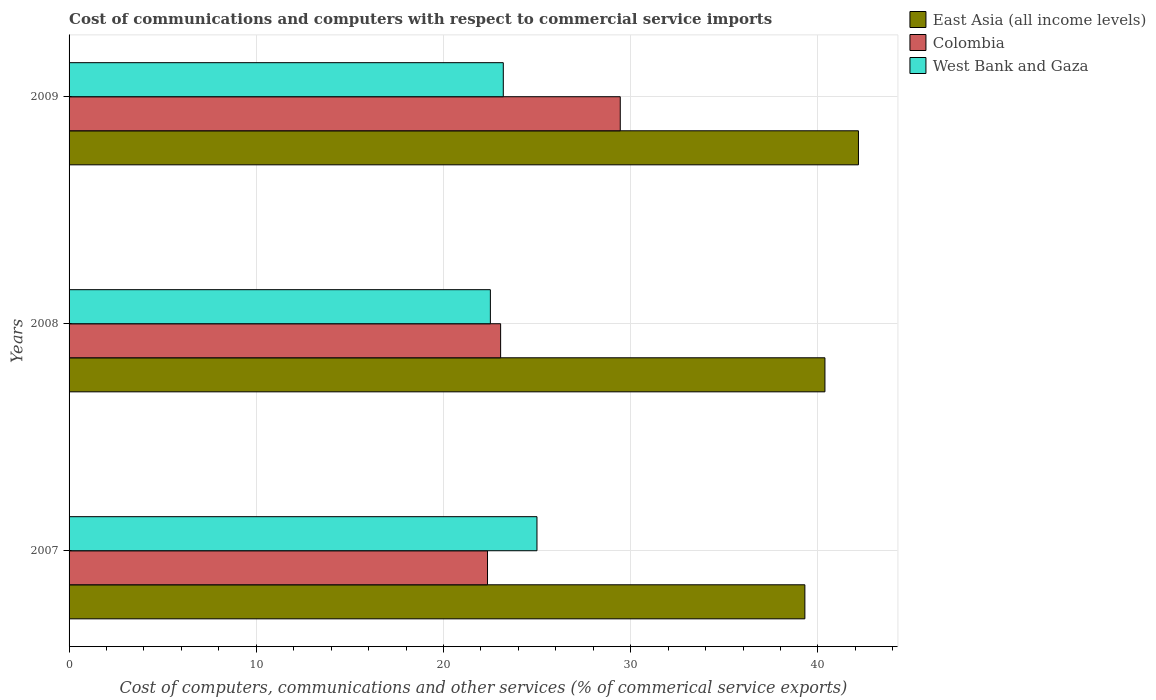How many different coloured bars are there?
Keep it short and to the point. 3. Are the number of bars on each tick of the Y-axis equal?
Make the answer very short. Yes. How many bars are there on the 2nd tick from the bottom?
Offer a very short reply. 3. What is the label of the 2nd group of bars from the top?
Give a very brief answer. 2008. What is the cost of communications and computers in West Bank and Gaza in 2007?
Make the answer very short. 24.99. Across all years, what is the maximum cost of communications and computers in Colombia?
Your answer should be very brief. 29.44. Across all years, what is the minimum cost of communications and computers in Colombia?
Offer a very short reply. 22.35. In which year was the cost of communications and computers in Colombia minimum?
Ensure brevity in your answer.  2007. What is the total cost of communications and computers in West Bank and Gaza in the graph?
Ensure brevity in your answer.  70.69. What is the difference between the cost of communications and computers in Colombia in 2008 and that in 2009?
Keep it short and to the point. -6.39. What is the difference between the cost of communications and computers in East Asia (all income levels) in 2009 and the cost of communications and computers in West Bank and Gaza in 2008?
Give a very brief answer. 19.66. What is the average cost of communications and computers in West Bank and Gaza per year?
Provide a succinct answer. 23.56. In the year 2007, what is the difference between the cost of communications and computers in East Asia (all income levels) and cost of communications and computers in West Bank and Gaza?
Your response must be concise. 14.31. In how many years, is the cost of communications and computers in West Bank and Gaza greater than 36 %?
Provide a succinct answer. 0. What is the ratio of the cost of communications and computers in West Bank and Gaza in 2008 to that in 2009?
Give a very brief answer. 0.97. Is the cost of communications and computers in Colombia in 2007 less than that in 2008?
Your answer should be compact. Yes. What is the difference between the highest and the second highest cost of communications and computers in Colombia?
Give a very brief answer. 6.39. What is the difference between the highest and the lowest cost of communications and computers in Colombia?
Your answer should be compact. 7.09. In how many years, is the cost of communications and computers in East Asia (all income levels) greater than the average cost of communications and computers in East Asia (all income levels) taken over all years?
Give a very brief answer. 1. Is the sum of the cost of communications and computers in West Bank and Gaza in 2008 and 2009 greater than the maximum cost of communications and computers in Colombia across all years?
Give a very brief answer. Yes. What does the 1st bar from the top in 2007 represents?
Offer a very short reply. West Bank and Gaza. What does the 1st bar from the bottom in 2008 represents?
Your answer should be very brief. East Asia (all income levels). Is it the case that in every year, the sum of the cost of communications and computers in Colombia and cost of communications and computers in West Bank and Gaza is greater than the cost of communications and computers in East Asia (all income levels)?
Keep it short and to the point. Yes. How many bars are there?
Keep it short and to the point. 9. Are all the bars in the graph horizontal?
Make the answer very short. Yes. What is the title of the graph?
Keep it short and to the point. Cost of communications and computers with respect to commercial service imports. What is the label or title of the X-axis?
Provide a short and direct response. Cost of computers, communications and other services (% of commerical service exports). What is the Cost of computers, communications and other services (% of commerical service exports) of East Asia (all income levels) in 2007?
Offer a terse response. 39.3. What is the Cost of computers, communications and other services (% of commerical service exports) in Colombia in 2007?
Offer a very short reply. 22.35. What is the Cost of computers, communications and other services (% of commerical service exports) of West Bank and Gaza in 2007?
Keep it short and to the point. 24.99. What is the Cost of computers, communications and other services (% of commerical service exports) of East Asia (all income levels) in 2008?
Your answer should be compact. 40.37. What is the Cost of computers, communications and other services (% of commerical service exports) in Colombia in 2008?
Offer a terse response. 23.05. What is the Cost of computers, communications and other services (% of commerical service exports) of West Bank and Gaza in 2008?
Provide a short and direct response. 22.5. What is the Cost of computers, communications and other services (% of commerical service exports) in East Asia (all income levels) in 2009?
Ensure brevity in your answer.  42.16. What is the Cost of computers, communications and other services (% of commerical service exports) in Colombia in 2009?
Your answer should be compact. 29.44. What is the Cost of computers, communications and other services (% of commerical service exports) of West Bank and Gaza in 2009?
Provide a succinct answer. 23.19. Across all years, what is the maximum Cost of computers, communications and other services (% of commerical service exports) of East Asia (all income levels)?
Provide a short and direct response. 42.16. Across all years, what is the maximum Cost of computers, communications and other services (% of commerical service exports) in Colombia?
Your answer should be compact. 29.44. Across all years, what is the maximum Cost of computers, communications and other services (% of commerical service exports) in West Bank and Gaza?
Ensure brevity in your answer.  24.99. Across all years, what is the minimum Cost of computers, communications and other services (% of commerical service exports) in East Asia (all income levels)?
Your answer should be compact. 39.3. Across all years, what is the minimum Cost of computers, communications and other services (% of commerical service exports) of Colombia?
Make the answer very short. 22.35. Across all years, what is the minimum Cost of computers, communications and other services (% of commerical service exports) in West Bank and Gaza?
Your answer should be compact. 22.5. What is the total Cost of computers, communications and other services (% of commerical service exports) in East Asia (all income levels) in the graph?
Keep it short and to the point. 121.84. What is the total Cost of computers, communications and other services (% of commerical service exports) of Colombia in the graph?
Your answer should be very brief. 74.84. What is the total Cost of computers, communications and other services (% of commerical service exports) of West Bank and Gaza in the graph?
Make the answer very short. 70.69. What is the difference between the Cost of computers, communications and other services (% of commerical service exports) of East Asia (all income levels) in 2007 and that in 2008?
Provide a short and direct response. -1.07. What is the difference between the Cost of computers, communications and other services (% of commerical service exports) of Colombia in 2007 and that in 2008?
Offer a very short reply. -0.7. What is the difference between the Cost of computers, communications and other services (% of commerical service exports) of West Bank and Gaza in 2007 and that in 2008?
Give a very brief answer. 2.49. What is the difference between the Cost of computers, communications and other services (% of commerical service exports) of East Asia (all income levels) in 2007 and that in 2009?
Offer a terse response. -2.86. What is the difference between the Cost of computers, communications and other services (% of commerical service exports) in Colombia in 2007 and that in 2009?
Offer a terse response. -7.09. What is the difference between the Cost of computers, communications and other services (% of commerical service exports) in West Bank and Gaza in 2007 and that in 2009?
Provide a short and direct response. 1.8. What is the difference between the Cost of computers, communications and other services (% of commerical service exports) of East Asia (all income levels) in 2008 and that in 2009?
Keep it short and to the point. -1.79. What is the difference between the Cost of computers, communications and other services (% of commerical service exports) of Colombia in 2008 and that in 2009?
Make the answer very short. -6.39. What is the difference between the Cost of computers, communications and other services (% of commerical service exports) in West Bank and Gaza in 2008 and that in 2009?
Provide a succinct answer. -0.69. What is the difference between the Cost of computers, communications and other services (% of commerical service exports) in East Asia (all income levels) in 2007 and the Cost of computers, communications and other services (% of commerical service exports) in Colombia in 2008?
Keep it short and to the point. 16.25. What is the difference between the Cost of computers, communications and other services (% of commerical service exports) of East Asia (all income levels) in 2007 and the Cost of computers, communications and other services (% of commerical service exports) of West Bank and Gaza in 2008?
Ensure brevity in your answer.  16.8. What is the difference between the Cost of computers, communications and other services (% of commerical service exports) of Colombia in 2007 and the Cost of computers, communications and other services (% of commerical service exports) of West Bank and Gaza in 2008?
Offer a terse response. -0.15. What is the difference between the Cost of computers, communications and other services (% of commerical service exports) in East Asia (all income levels) in 2007 and the Cost of computers, communications and other services (% of commerical service exports) in Colombia in 2009?
Offer a terse response. 9.86. What is the difference between the Cost of computers, communications and other services (% of commerical service exports) of East Asia (all income levels) in 2007 and the Cost of computers, communications and other services (% of commerical service exports) of West Bank and Gaza in 2009?
Provide a short and direct response. 16.11. What is the difference between the Cost of computers, communications and other services (% of commerical service exports) in Colombia in 2007 and the Cost of computers, communications and other services (% of commerical service exports) in West Bank and Gaza in 2009?
Offer a terse response. -0.84. What is the difference between the Cost of computers, communications and other services (% of commerical service exports) in East Asia (all income levels) in 2008 and the Cost of computers, communications and other services (% of commerical service exports) in Colombia in 2009?
Provide a succinct answer. 10.93. What is the difference between the Cost of computers, communications and other services (% of commerical service exports) of East Asia (all income levels) in 2008 and the Cost of computers, communications and other services (% of commerical service exports) of West Bank and Gaza in 2009?
Make the answer very short. 17.18. What is the difference between the Cost of computers, communications and other services (% of commerical service exports) of Colombia in 2008 and the Cost of computers, communications and other services (% of commerical service exports) of West Bank and Gaza in 2009?
Offer a very short reply. -0.14. What is the average Cost of computers, communications and other services (% of commerical service exports) of East Asia (all income levels) per year?
Your answer should be compact. 40.61. What is the average Cost of computers, communications and other services (% of commerical service exports) in Colombia per year?
Your response must be concise. 24.95. What is the average Cost of computers, communications and other services (% of commerical service exports) of West Bank and Gaza per year?
Give a very brief answer. 23.56. In the year 2007, what is the difference between the Cost of computers, communications and other services (% of commerical service exports) of East Asia (all income levels) and Cost of computers, communications and other services (% of commerical service exports) of Colombia?
Your answer should be very brief. 16.95. In the year 2007, what is the difference between the Cost of computers, communications and other services (% of commerical service exports) in East Asia (all income levels) and Cost of computers, communications and other services (% of commerical service exports) in West Bank and Gaza?
Ensure brevity in your answer.  14.31. In the year 2007, what is the difference between the Cost of computers, communications and other services (% of commerical service exports) in Colombia and Cost of computers, communications and other services (% of commerical service exports) in West Bank and Gaza?
Give a very brief answer. -2.64. In the year 2008, what is the difference between the Cost of computers, communications and other services (% of commerical service exports) of East Asia (all income levels) and Cost of computers, communications and other services (% of commerical service exports) of Colombia?
Your answer should be very brief. 17.32. In the year 2008, what is the difference between the Cost of computers, communications and other services (% of commerical service exports) in East Asia (all income levels) and Cost of computers, communications and other services (% of commerical service exports) in West Bank and Gaza?
Ensure brevity in your answer.  17.87. In the year 2008, what is the difference between the Cost of computers, communications and other services (% of commerical service exports) in Colombia and Cost of computers, communications and other services (% of commerical service exports) in West Bank and Gaza?
Offer a terse response. 0.55. In the year 2009, what is the difference between the Cost of computers, communications and other services (% of commerical service exports) in East Asia (all income levels) and Cost of computers, communications and other services (% of commerical service exports) in Colombia?
Your answer should be compact. 12.72. In the year 2009, what is the difference between the Cost of computers, communications and other services (% of commerical service exports) in East Asia (all income levels) and Cost of computers, communications and other services (% of commerical service exports) in West Bank and Gaza?
Provide a short and direct response. 18.97. In the year 2009, what is the difference between the Cost of computers, communications and other services (% of commerical service exports) of Colombia and Cost of computers, communications and other services (% of commerical service exports) of West Bank and Gaza?
Your answer should be compact. 6.25. What is the ratio of the Cost of computers, communications and other services (% of commerical service exports) of East Asia (all income levels) in 2007 to that in 2008?
Your answer should be very brief. 0.97. What is the ratio of the Cost of computers, communications and other services (% of commerical service exports) in Colombia in 2007 to that in 2008?
Provide a short and direct response. 0.97. What is the ratio of the Cost of computers, communications and other services (% of commerical service exports) of West Bank and Gaza in 2007 to that in 2008?
Make the answer very short. 1.11. What is the ratio of the Cost of computers, communications and other services (% of commerical service exports) of East Asia (all income levels) in 2007 to that in 2009?
Make the answer very short. 0.93. What is the ratio of the Cost of computers, communications and other services (% of commerical service exports) of Colombia in 2007 to that in 2009?
Keep it short and to the point. 0.76. What is the ratio of the Cost of computers, communications and other services (% of commerical service exports) of West Bank and Gaza in 2007 to that in 2009?
Offer a very short reply. 1.08. What is the ratio of the Cost of computers, communications and other services (% of commerical service exports) of East Asia (all income levels) in 2008 to that in 2009?
Your answer should be compact. 0.96. What is the ratio of the Cost of computers, communications and other services (% of commerical service exports) in Colombia in 2008 to that in 2009?
Give a very brief answer. 0.78. What is the ratio of the Cost of computers, communications and other services (% of commerical service exports) of West Bank and Gaza in 2008 to that in 2009?
Provide a short and direct response. 0.97. What is the difference between the highest and the second highest Cost of computers, communications and other services (% of commerical service exports) in East Asia (all income levels)?
Your answer should be very brief. 1.79. What is the difference between the highest and the second highest Cost of computers, communications and other services (% of commerical service exports) of Colombia?
Your answer should be very brief. 6.39. What is the difference between the highest and the second highest Cost of computers, communications and other services (% of commerical service exports) of West Bank and Gaza?
Make the answer very short. 1.8. What is the difference between the highest and the lowest Cost of computers, communications and other services (% of commerical service exports) in East Asia (all income levels)?
Keep it short and to the point. 2.86. What is the difference between the highest and the lowest Cost of computers, communications and other services (% of commerical service exports) of Colombia?
Keep it short and to the point. 7.09. What is the difference between the highest and the lowest Cost of computers, communications and other services (% of commerical service exports) of West Bank and Gaza?
Your response must be concise. 2.49. 